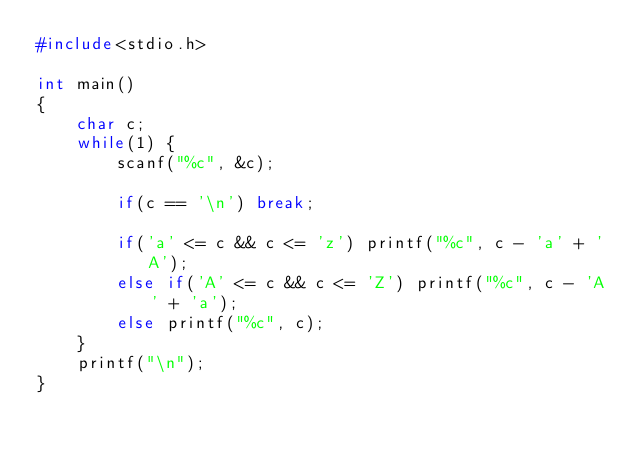<code> <loc_0><loc_0><loc_500><loc_500><_C_>#include<stdio.h>

int main()
{
    char c;
    while(1) {
        scanf("%c", &c);

        if(c == '\n') break;

        if('a' <= c && c <= 'z') printf("%c", c - 'a' + 'A');
        else if('A' <= c && c <= 'Z') printf("%c", c - 'A' + 'a');
        else printf("%c", c);
    }
    printf("\n");
}

</code> 